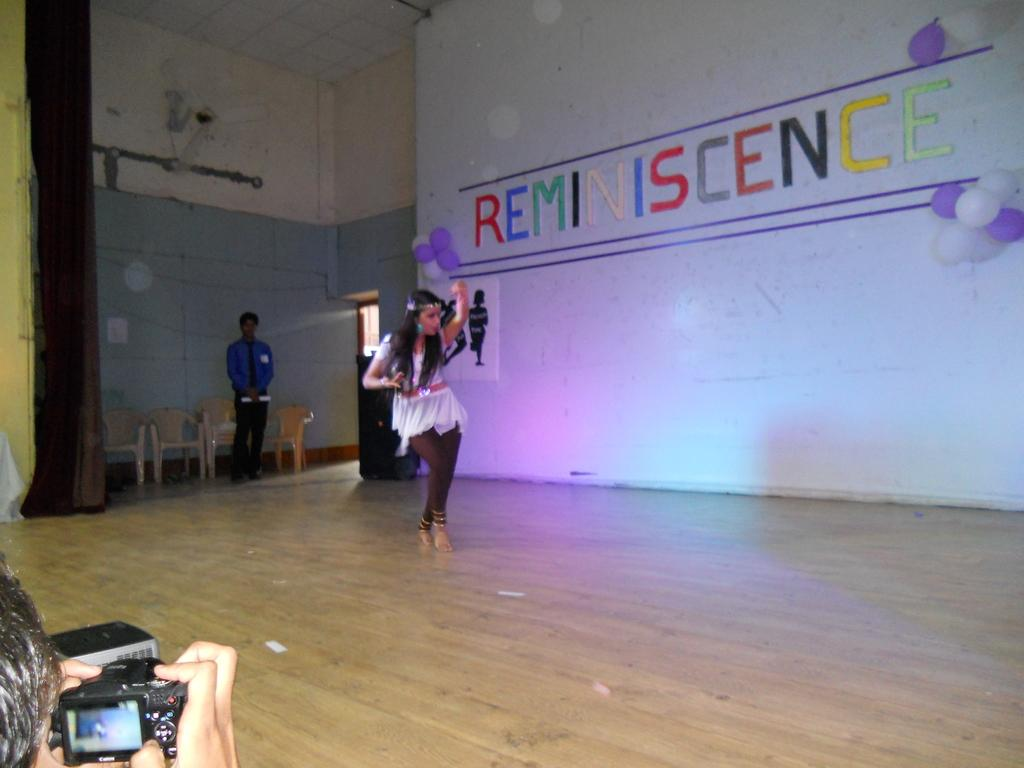What is the main action being performed by one of the persons in the image? There is a person dancing in the image. What is another person doing in the image? There is a person standing in the image. Who is holding a camera in the image? There is a person holding a camera in the image. What decorative items can be seen on the wall in the image? There are balloons on the wall in the image. What type of furniture is present in the image? There are chairs in the image. What device can be seen providing air circulation in the image? There is a fan in the image. Can you describe the garden visible in the image? There is no garden present in the image. How many snakes are slithering on the floor in the image? There are no snakes present in the image. 